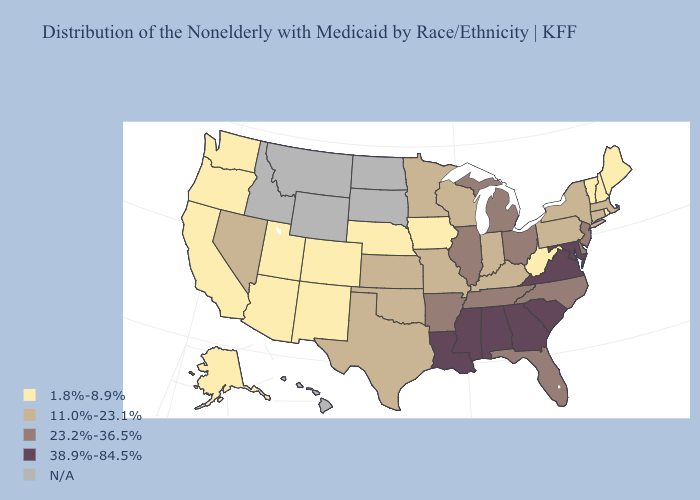What is the lowest value in the West?
Give a very brief answer. 1.8%-8.9%. Does Oklahoma have the lowest value in the USA?
Keep it brief. No. Name the states that have a value in the range 23.2%-36.5%?
Write a very short answer. Arkansas, Delaware, Florida, Illinois, Michigan, New Jersey, North Carolina, Ohio, Tennessee. What is the highest value in states that border Missouri?
Quick response, please. 23.2%-36.5%. Which states have the highest value in the USA?
Quick response, please. Alabama, Georgia, Louisiana, Maryland, Mississippi, South Carolina, Virginia. How many symbols are there in the legend?
Write a very short answer. 5. What is the value of Ohio?
Write a very short answer. 23.2%-36.5%. What is the value of North Dakota?
Give a very brief answer. N/A. Does New Jersey have the highest value in the Northeast?
Be succinct. Yes. What is the value of Illinois?
Quick response, please. 23.2%-36.5%. What is the value of Florida?
Be succinct. 23.2%-36.5%. Does Pennsylvania have the highest value in the USA?
Answer briefly. No. Among the states that border Iowa , does Nebraska have the lowest value?
Keep it brief. Yes. Which states have the highest value in the USA?
Short answer required. Alabama, Georgia, Louisiana, Maryland, Mississippi, South Carolina, Virginia. 